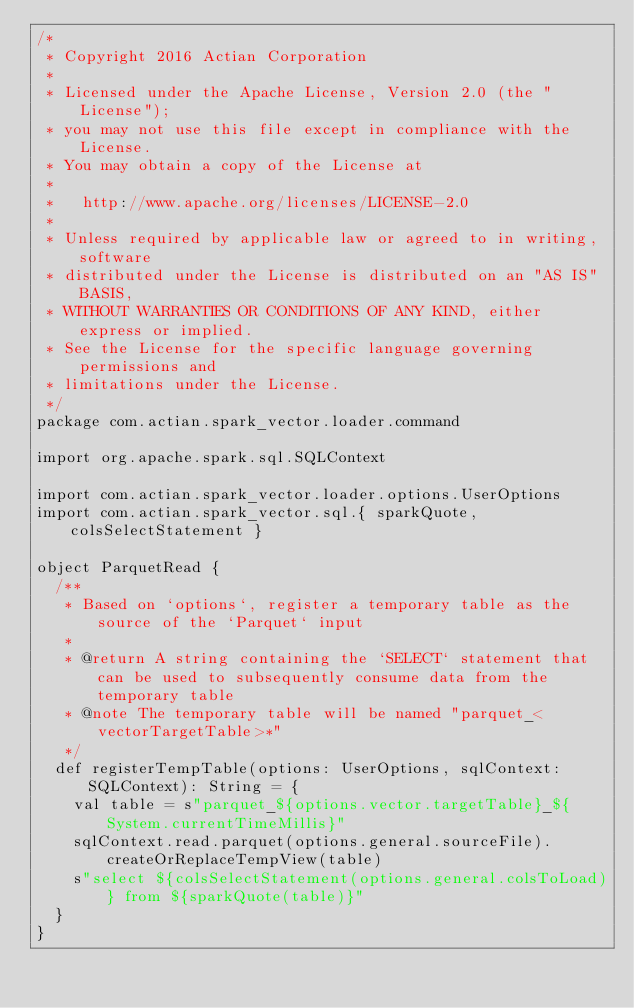<code> <loc_0><loc_0><loc_500><loc_500><_Scala_>/*
 * Copyright 2016 Actian Corporation
 *
 * Licensed under the Apache License, Version 2.0 (the "License");
 * you may not use this file except in compliance with the License.
 * You may obtain a copy of the License at
 *
 *   http://www.apache.org/licenses/LICENSE-2.0
 *
 * Unless required by applicable law or agreed to in writing, software
 * distributed under the License is distributed on an "AS IS" BASIS,
 * WITHOUT WARRANTIES OR CONDITIONS OF ANY KIND, either express or implied.
 * See the License for the specific language governing permissions and
 * limitations under the License.
 */
package com.actian.spark_vector.loader.command

import org.apache.spark.sql.SQLContext

import com.actian.spark_vector.loader.options.UserOptions
import com.actian.spark_vector.sql.{ sparkQuote, colsSelectStatement }

object ParquetRead {
  /**
   * Based on `options`, register a temporary table as the source of the `Parquet` input
   *
   * @return A string containing the `SELECT` statement that can be used to subsequently consume data from the temporary table
   * @note The temporary table will be named "parquet_<vectorTargetTable>*"
   */
  def registerTempTable(options: UserOptions, sqlContext: SQLContext): String = {
    val table = s"parquet_${options.vector.targetTable}_${System.currentTimeMillis}"
    sqlContext.read.parquet(options.general.sourceFile).createOrReplaceTempView(table)
    s"select ${colsSelectStatement(options.general.colsToLoad)} from ${sparkQuote(table)}"
  }
}
</code> 